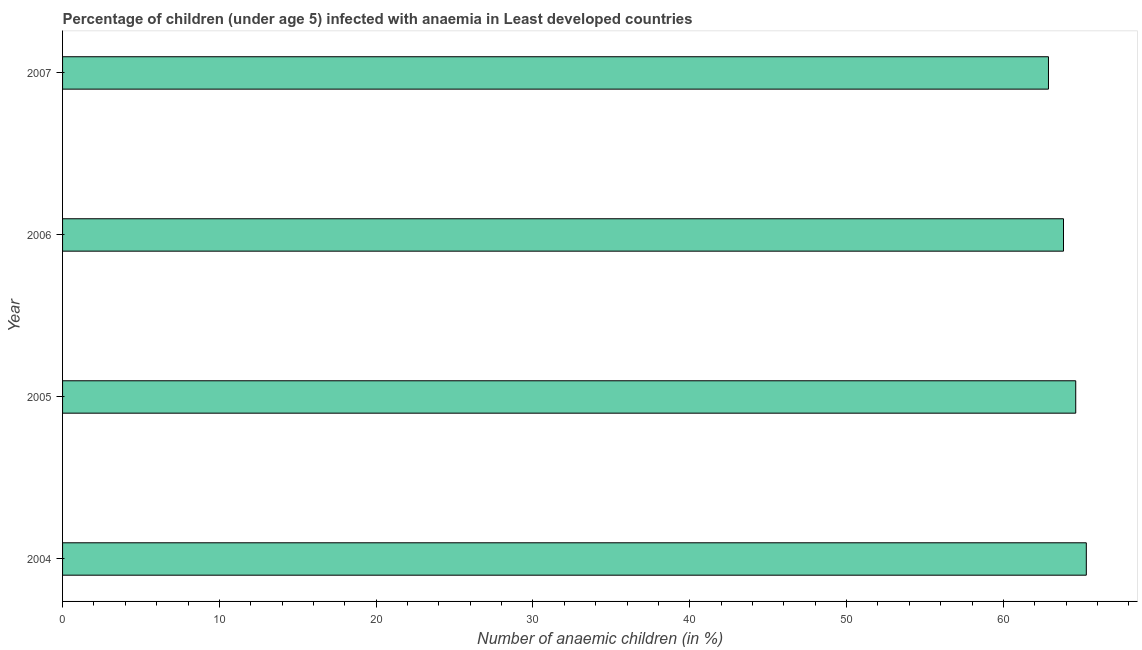Does the graph contain any zero values?
Give a very brief answer. No. Does the graph contain grids?
Your response must be concise. No. What is the title of the graph?
Your answer should be very brief. Percentage of children (under age 5) infected with anaemia in Least developed countries. What is the label or title of the X-axis?
Ensure brevity in your answer.  Number of anaemic children (in %). What is the number of anaemic children in 2006?
Your answer should be compact. 63.84. Across all years, what is the maximum number of anaemic children?
Provide a short and direct response. 65.29. Across all years, what is the minimum number of anaemic children?
Ensure brevity in your answer.  62.88. In which year was the number of anaemic children minimum?
Provide a succinct answer. 2007. What is the sum of the number of anaemic children?
Ensure brevity in your answer.  256.62. What is the difference between the number of anaemic children in 2005 and 2006?
Your response must be concise. 0.78. What is the average number of anaemic children per year?
Your answer should be very brief. 64.16. What is the median number of anaemic children?
Provide a succinct answer. 64.23. In how many years, is the number of anaemic children greater than 20 %?
Your response must be concise. 4. Is the difference between the number of anaemic children in 2004 and 2005 greater than the difference between any two years?
Make the answer very short. No. What is the difference between the highest and the second highest number of anaemic children?
Keep it short and to the point. 0.67. Is the sum of the number of anaemic children in 2004 and 2007 greater than the maximum number of anaemic children across all years?
Your answer should be very brief. Yes. What is the difference between the highest and the lowest number of anaemic children?
Ensure brevity in your answer.  2.41. How many bars are there?
Your answer should be compact. 4. How many years are there in the graph?
Your response must be concise. 4. What is the difference between two consecutive major ticks on the X-axis?
Your answer should be compact. 10. Are the values on the major ticks of X-axis written in scientific E-notation?
Your response must be concise. No. What is the Number of anaemic children (in %) of 2004?
Offer a very short reply. 65.29. What is the Number of anaemic children (in %) in 2005?
Offer a terse response. 64.62. What is the Number of anaemic children (in %) in 2006?
Your answer should be very brief. 63.84. What is the Number of anaemic children (in %) in 2007?
Your response must be concise. 62.88. What is the difference between the Number of anaemic children (in %) in 2004 and 2005?
Keep it short and to the point. 0.67. What is the difference between the Number of anaemic children (in %) in 2004 and 2006?
Offer a very short reply. 1.45. What is the difference between the Number of anaemic children (in %) in 2004 and 2007?
Your answer should be compact. 2.41. What is the difference between the Number of anaemic children (in %) in 2005 and 2006?
Offer a terse response. 0.78. What is the difference between the Number of anaemic children (in %) in 2005 and 2007?
Give a very brief answer. 1.74. What is the difference between the Number of anaemic children (in %) in 2006 and 2007?
Offer a very short reply. 0.96. What is the ratio of the Number of anaemic children (in %) in 2004 to that in 2005?
Give a very brief answer. 1.01. What is the ratio of the Number of anaemic children (in %) in 2004 to that in 2007?
Provide a short and direct response. 1.04. What is the ratio of the Number of anaemic children (in %) in 2005 to that in 2007?
Give a very brief answer. 1.03. What is the ratio of the Number of anaemic children (in %) in 2006 to that in 2007?
Offer a terse response. 1.01. 